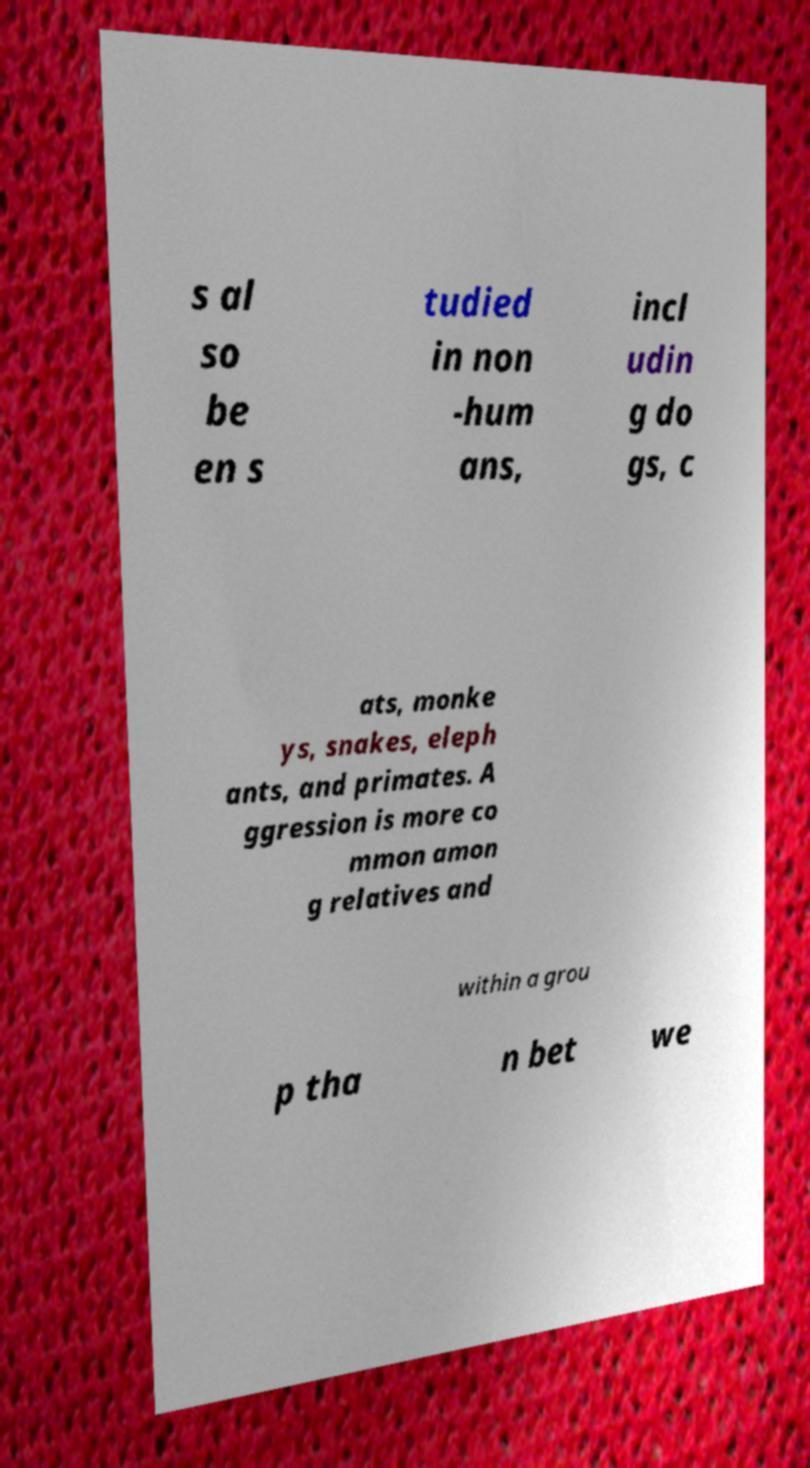What messages or text are displayed in this image? I need them in a readable, typed format. s al so be en s tudied in non -hum ans, incl udin g do gs, c ats, monke ys, snakes, eleph ants, and primates. A ggression is more co mmon amon g relatives and within a grou p tha n bet we 